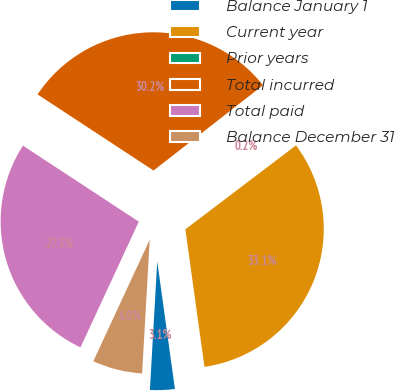Convert chart. <chart><loc_0><loc_0><loc_500><loc_500><pie_chart><fcel>Balance January 1<fcel>Current year<fcel>Prior years<fcel>Total incurred<fcel>Total paid<fcel>Balance December 31<nl><fcel>3.1%<fcel>33.14%<fcel>0.2%<fcel>30.23%<fcel>27.33%<fcel>6.01%<nl></chart> 